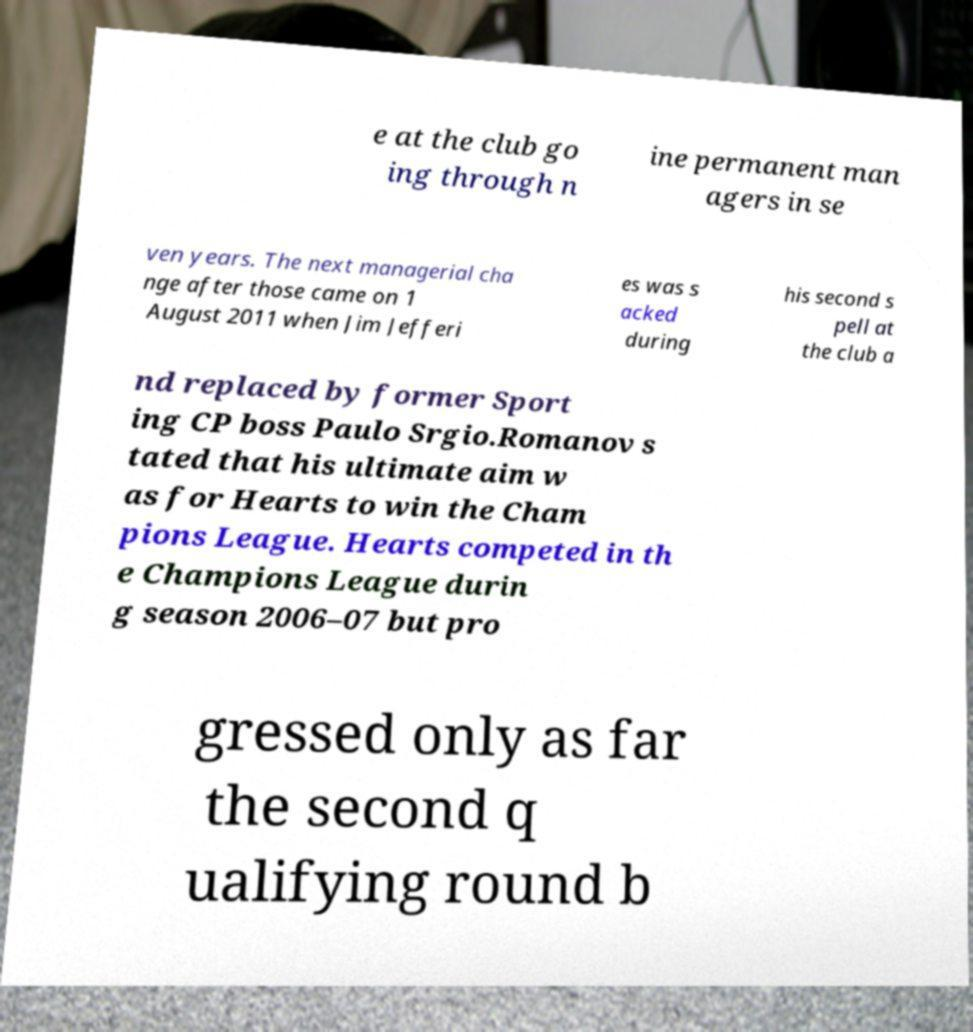Can you read and provide the text displayed in the image?This photo seems to have some interesting text. Can you extract and type it out for me? e at the club go ing through n ine permanent man agers in se ven years. The next managerial cha nge after those came on 1 August 2011 when Jim Jefferi es was s acked during his second s pell at the club a nd replaced by former Sport ing CP boss Paulo Srgio.Romanov s tated that his ultimate aim w as for Hearts to win the Cham pions League. Hearts competed in th e Champions League durin g season 2006–07 but pro gressed only as far the second q ualifying round b 